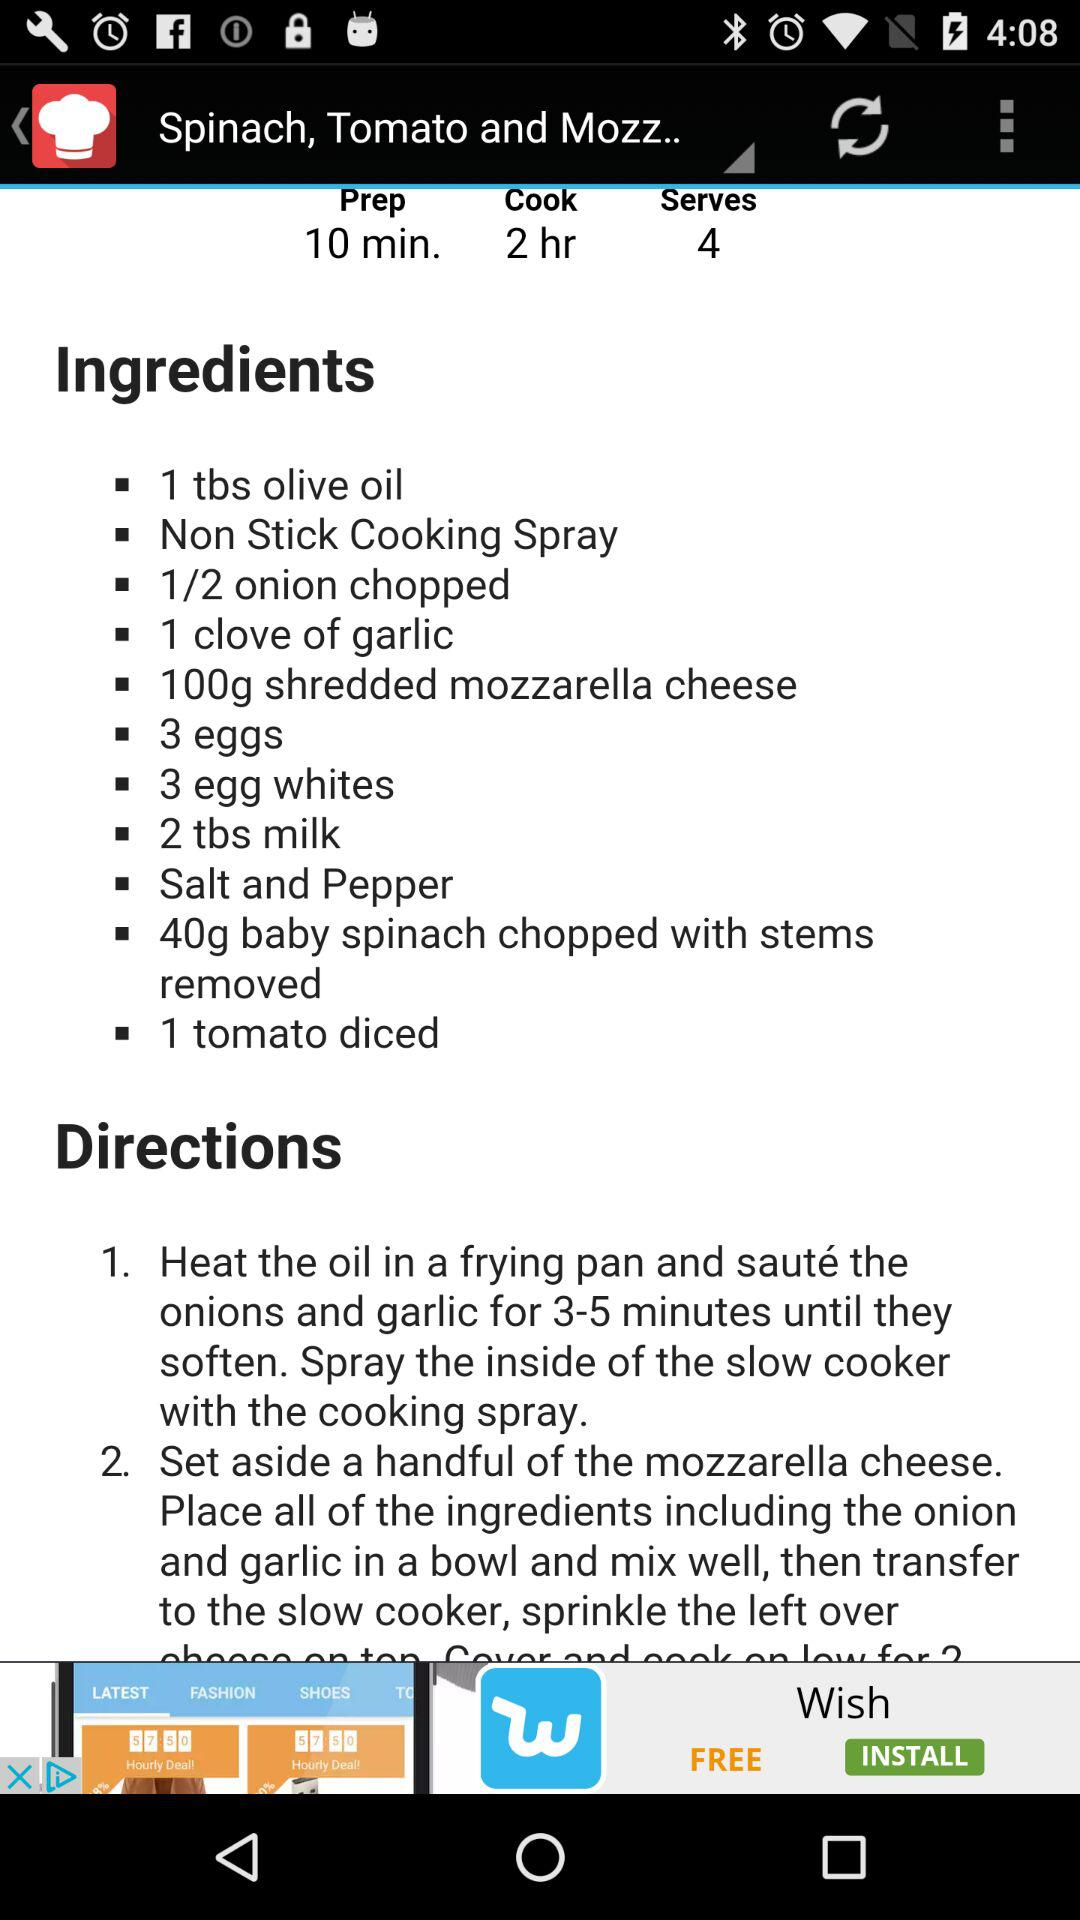How many tomatoes do we need for the dish? You need 1 tomato for the dish. 